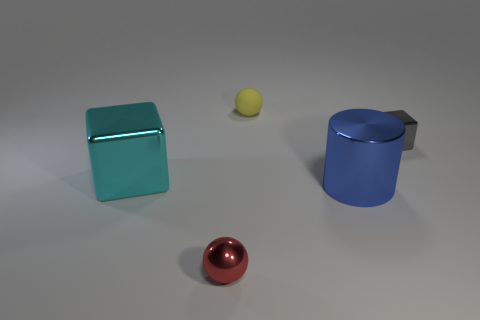Add 3 cubes. How many objects exist? 8 Subtract all blocks. How many objects are left? 3 Subtract all blue metallic cylinders. Subtract all big shiny cylinders. How many objects are left? 3 Add 3 blue cylinders. How many blue cylinders are left? 4 Add 1 blue things. How many blue things exist? 2 Subtract 0 purple balls. How many objects are left? 5 